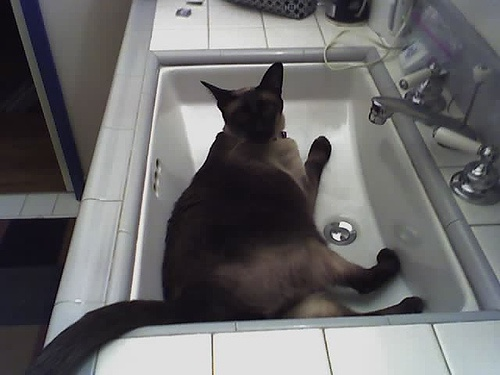Describe the objects in this image and their specific colors. I can see sink in black, gray, darkgray, and lightgray tones and cat in black and gray tones in this image. 